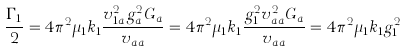Convert formula to latex. <formula><loc_0><loc_0><loc_500><loc_500>\frac { \Gamma _ { 1 } } { 2 } = 4 \pi ^ { 2 } \mu _ { 1 } k _ { 1 } \frac { v _ { 1 a } ^ { 2 } g _ { a } ^ { 2 } G _ { a } } { v _ { a a } } = 4 \pi ^ { 2 } \mu _ { 1 } k _ { 1 } \frac { g _ { 1 } ^ { 2 } v _ { a a } ^ { 2 } G _ { a } } { v _ { a a } } = 4 \pi ^ { 2 } \mu _ { 1 } k _ { 1 } g _ { 1 } ^ { 2 }</formula> 